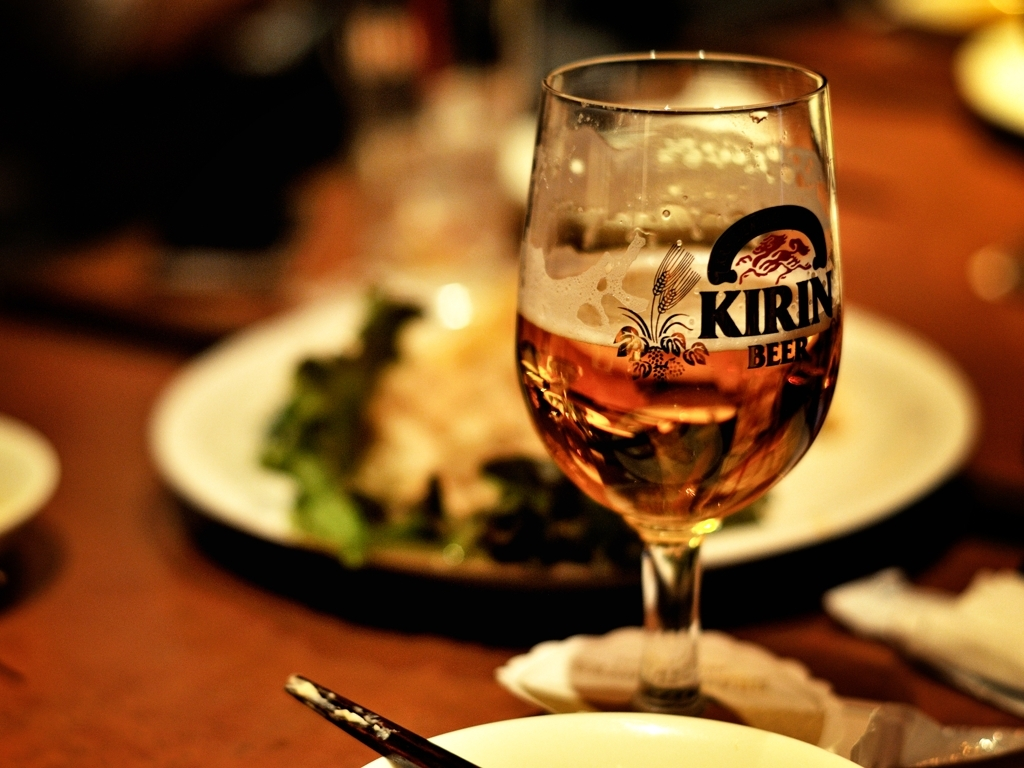Can you tell me about the setting of this image? The image appears to be taken in an indoor setting, likely at a dining venue, given the presence of a partly consumed beverage and plates with food residue. The warm ambiance suggests a casual dining atmosphere. 